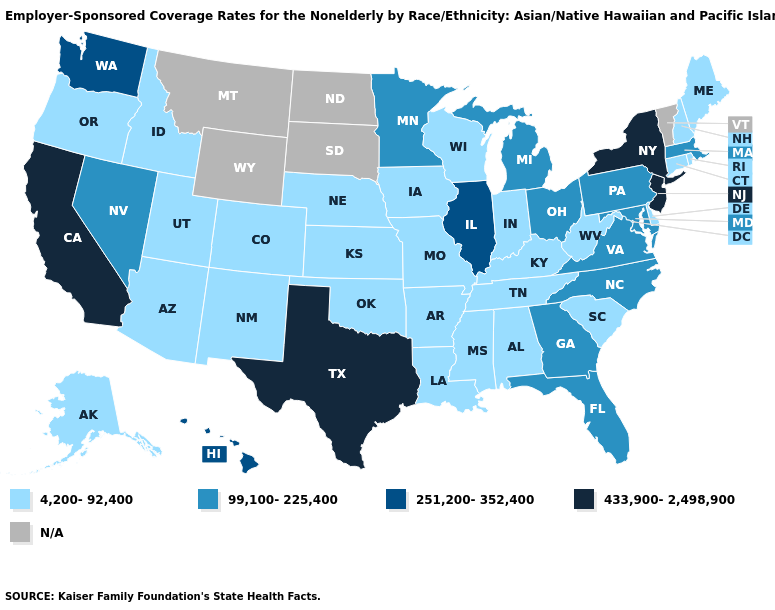What is the value of Iowa?
Concise answer only. 4,200-92,400. Name the states that have a value in the range 4,200-92,400?
Quick response, please. Alabama, Alaska, Arizona, Arkansas, Colorado, Connecticut, Delaware, Idaho, Indiana, Iowa, Kansas, Kentucky, Louisiana, Maine, Mississippi, Missouri, Nebraska, New Hampshire, New Mexico, Oklahoma, Oregon, Rhode Island, South Carolina, Tennessee, Utah, West Virginia, Wisconsin. How many symbols are there in the legend?
Concise answer only. 5. How many symbols are there in the legend?
Answer briefly. 5. What is the value of New York?
Write a very short answer. 433,900-2,498,900. Name the states that have a value in the range 433,900-2,498,900?
Write a very short answer. California, New Jersey, New York, Texas. Which states hav the highest value in the South?
Be succinct. Texas. How many symbols are there in the legend?
Answer briefly. 5. What is the lowest value in the USA?
Answer briefly. 4,200-92,400. What is the value of Arkansas?
Quick response, please. 4,200-92,400. Which states have the highest value in the USA?
Answer briefly. California, New Jersey, New York, Texas. Does Minnesota have the highest value in the USA?
Answer briefly. No. 